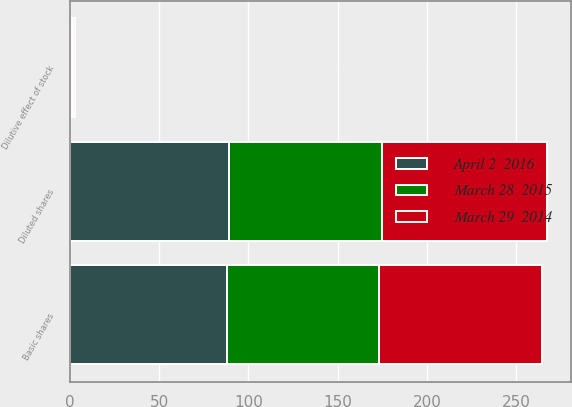<chart> <loc_0><loc_0><loc_500><loc_500><stacked_bar_chart><ecel><fcel>Basic shares<fcel>Dilutive effect of stock<fcel>Diluted shares<nl><fcel>March 28  2015<fcel>85.2<fcel>0.7<fcel>85.9<nl><fcel>April 2  2016<fcel>88.2<fcel>0.9<fcel>89.1<nl><fcel>March 29  2014<fcel>90.7<fcel>1.3<fcel>92<nl></chart> 